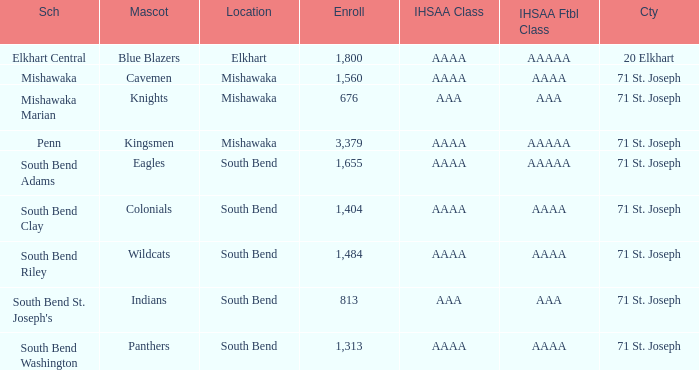What location has an enrollment greater than 1,313, and kingsmen as the mascot? Mishawaka. 